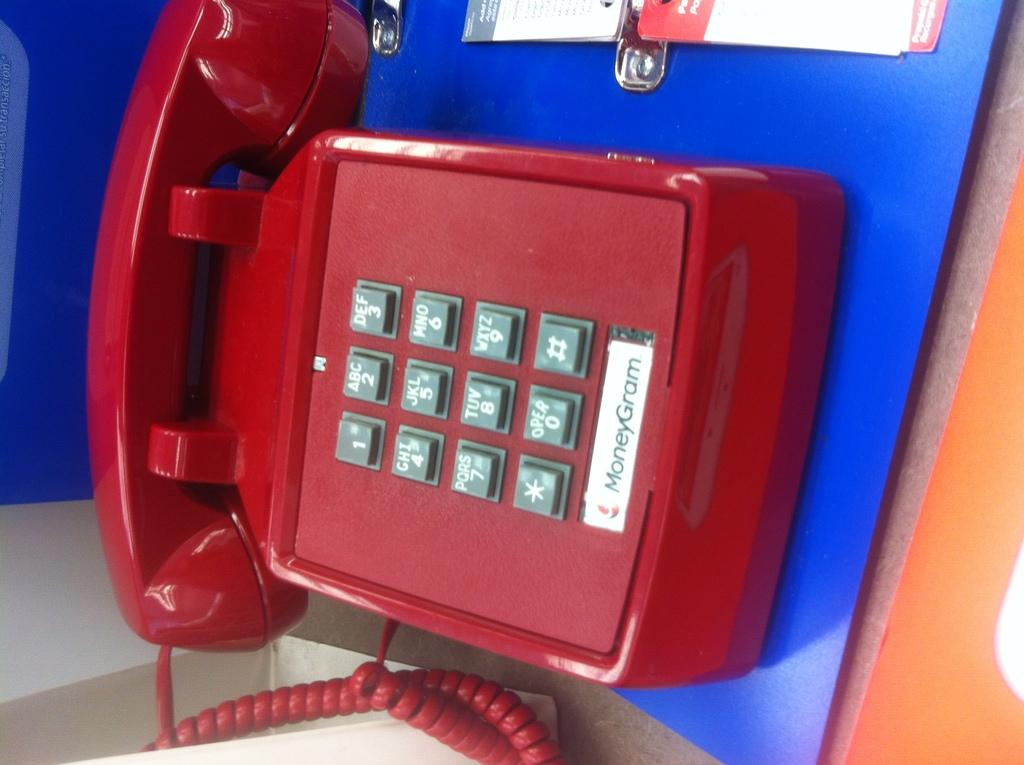What object is the main focus of the image? There is a telephone in the image. What color is the surface on which the telephone is placed? The telephone is on a blue surface. Are there any markings or text on the telephone? Yes, there is writing on the telephone. What else can be seen near the telephone? There are papers near the telephone. What type of lettuce is being used as a system to organize the papers near the telephone? There is no lettuce present in the image, nor is it being used as a system to organize papers. 